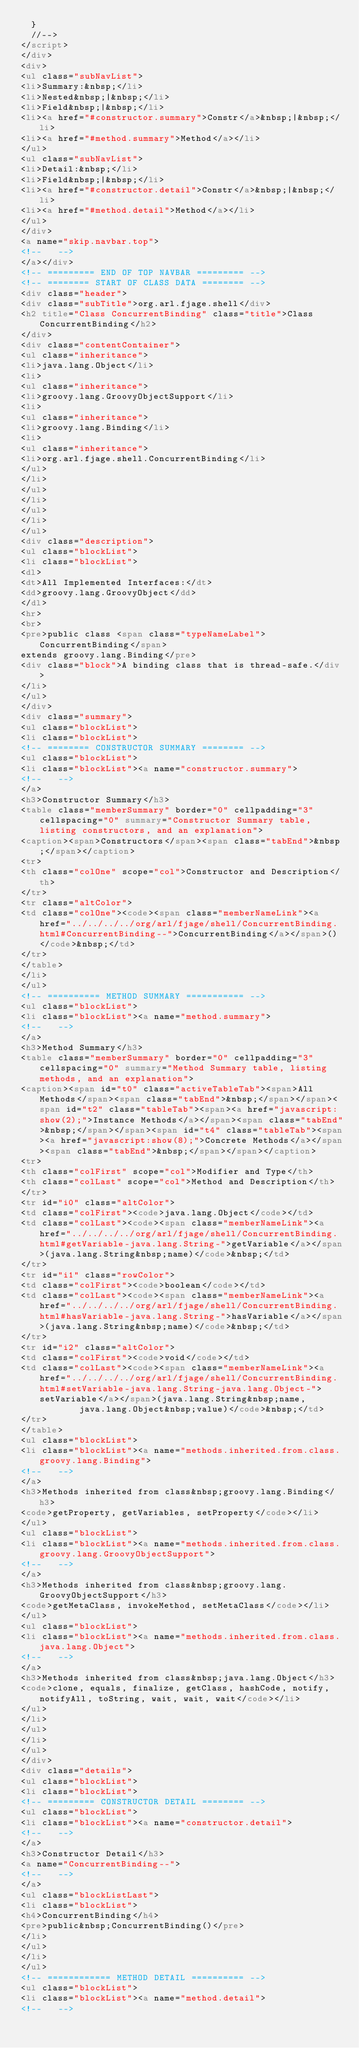<code> <loc_0><loc_0><loc_500><loc_500><_HTML_>  }
  //-->
</script>
</div>
<div>
<ul class="subNavList">
<li>Summary:&nbsp;</li>
<li>Nested&nbsp;|&nbsp;</li>
<li>Field&nbsp;|&nbsp;</li>
<li><a href="#constructor.summary">Constr</a>&nbsp;|&nbsp;</li>
<li><a href="#method.summary">Method</a></li>
</ul>
<ul class="subNavList">
<li>Detail:&nbsp;</li>
<li>Field&nbsp;|&nbsp;</li>
<li><a href="#constructor.detail">Constr</a>&nbsp;|&nbsp;</li>
<li><a href="#method.detail">Method</a></li>
</ul>
</div>
<a name="skip.navbar.top">
<!--   -->
</a></div>
<!-- ========= END OF TOP NAVBAR ========= -->
<!-- ======== START OF CLASS DATA ======== -->
<div class="header">
<div class="subTitle">org.arl.fjage.shell</div>
<h2 title="Class ConcurrentBinding" class="title">Class ConcurrentBinding</h2>
</div>
<div class="contentContainer">
<ul class="inheritance">
<li>java.lang.Object</li>
<li>
<ul class="inheritance">
<li>groovy.lang.GroovyObjectSupport</li>
<li>
<ul class="inheritance">
<li>groovy.lang.Binding</li>
<li>
<ul class="inheritance">
<li>org.arl.fjage.shell.ConcurrentBinding</li>
</ul>
</li>
</ul>
</li>
</ul>
</li>
</ul>
<div class="description">
<ul class="blockList">
<li class="blockList">
<dl>
<dt>All Implemented Interfaces:</dt>
<dd>groovy.lang.GroovyObject</dd>
</dl>
<hr>
<br>
<pre>public class <span class="typeNameLabel">ConcurrentBinding</span>
extends groovy.lang.Binding</pre>
<div class="block">A binding class that is thread-safe.</div>
</li>
</ul>
</div>
<div class="summary">
<ul class="blockList">
<li class="blockList">
<!-- ======== CONSTRUCTOR SUMMARY ======== -->
<ul class="blockList">
<li class="blockList"><a name="constructor.summary">
<!--   -->
</a>
<h3>Constructor Summary</h3>
<table class="memberSummary" border="0" cellpadding="3" cellspacing="0" summary="Constructor Summary table, listing constructors, and an explanation">
<caption><span>Constructors</span><span class="tabEnd">&nbsp;</span></caption>
<tr>
<th class="colOne" scope="col">Constructor and Description</th>
</tr>
<tr class="altColor">
<td class="colOne"><code><span class="memberNameLink"><a href="../../../../org/arl/fjage/shell/ConcurrentBinding.html#ConcurrentBinding--">ConcurrentBinding</a></span>()</code>&nbsp;</td>
</tr>
</table>
</li>
</ul>
<!-- ========== METHOD SUMMARY =========== -->
<ul class="blockList">
<li class="blockList"><a name="method.summary">
<!--   -->
</a>
<h3>Method Summary</h3>
<table class="memberSummary" border="0" cellpadding="3" cellspacing="0" summary="Method Summary table, listing methods, and an explanation">
<caption><span id="t0" class="activeTableTab"><span>All Methods</span><span class="tabEnd">&nbsp;</span></span><span id="t2" class="tableTab"><span><a href="javascript:show(2);">Instance Methods</a></span><span class="tabEnd">&nbsp;</span></span><span id="t4" class="tableTab"><span><a href="javascript:show(8);">Concrete Methods</a></span><span class="tabEnd">&nbsp;</span></span></caption>
<tr>
<th class="colFirst" scope="col">Modifier and Type</th>
<th class="colLast" scope="col">Method and Description</th>
</tr>
<tr id="i0" class="altColor">
<td class="colFirst"><code>java.lang.Object</code></td>
<td class="colLast"><code><span class="memberNameLink"><a href="../../../../org/arl/fjage/shell/ConcurrentBinding.html#getVariable-java.lang.String-">getVariable</a></span>(java.lang.String&nbsp;name)</code>&nbsp;</td>
</tr>
<tr id="i1" class="rowColor">
<td class="colFirst"><code>boolean</code></td>
<td class="colLast"><code><span class="memberNameLink"><a href="../../../../org/arl/fjage/shell/ConcurrentBinding.html#hasVariable-java.lang.String-">hasVariable</a></span>(java.lang.String&nbsp;name)</code>&nbsp;</td>
</tr>
<tr id="i2" class="altColor">
<td class="colFirst"><code>void</code></td>
<td class="colLast"><code><span class="memberNameLink"><a href="../../../../org/arl/fjage/shell/ConcurrentBinding.html#setVariable-java.lang.String-java.lang.Object-">setVariable</a></span>(java.lang.String&nbsp;name,
           java.lang.Object&nbsp;value)</code>&nbsp;</td>
</tr>
</table>
<ul class="blockList">
<li class="blockList"><a name="methods.inherited.from.class.groovy.lang.Binding">
<!--   -->
</a>
<h3>Methods inherited from class&nbsp;groovy.lang.Binding</h3>
<code>getProperty, getVariables, setProperty</code></li>
</ul>
<ul class="blockList">
<li class="blockList"><a name="methods.inherited.from.class.groovy.lang.GroovyObjectSupport">
<!--   -->
</a>
<h3>Methods inherited from class&nbsp;groovy.lang.GroovyObjectSupport</h3>
<code>getMetaClass, invokeMethod, setMetaClass</code></li>
</ul>
<ul class="blockList">
<li class="blockList"><a name="methods.inherited.from.class.java.lang.Object">
<!--   -->
</a>
<h3>Methods inherited from class&nbsp;java.lang.Object</h3>
<code>clone, equals, finalize, getClass, hashCode, notify, notifyAll, toString, wait, wait, wait</code></li>
</ul>
</li>
</ul>
</li>
</ul>
</div>
<div class="details">
<ul class="blockList">
<li class="blockList">
<!-- ========= CONSTRUCTOR DETAIL ======== -->
<ul class="blockList">
<li class="blockList"><a name="constructor.detail">
<!--   -->
</a>
<h3>Constructor Detail</h3>
<a name="ConcurrentBinding--">
<!--   -->
</a>
<ul class="blockListLast">
<li class="blockList">
<h4>ConcurrentBinding</h4>
<pre>public&nbsp;ConcurrentBinding()</pre>
</li>
</ul>
</li>
</ul>
<!-- ============ METHOD DETAIL ========== -->
<ul class="blockList">
<li class="blockList"><a name="method.detail">
<!--   --></code> 